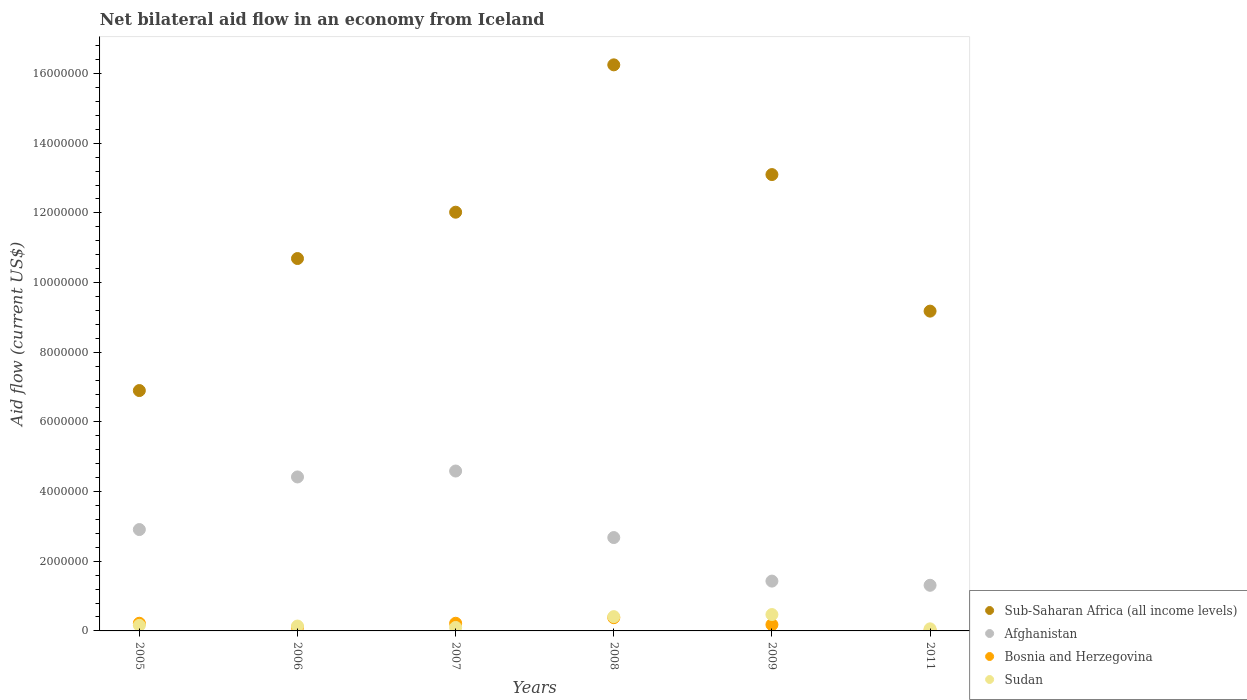How many different coloured dotlines are there?
Make the answer very short. 4. What is the net bilateral aid flow in Afghanistan in 2007?
Offer a terse response. 4.59e+06. Across all years, what is the maximum net bilateral aid flow in Bosnia and Herzegovina?
Your response must be concise. 3.80e+05. Across all years, what is the minimum net bilateral aid flow in Afghanistan?
Keep it short and to the point. 1.31e+06. In which year was the net bilateral aid flow in Bosnia and Herzegovina maximum?
Your response must be concise. 2008. In which year was the net bilateral aid flow in Sudan minimum?
Provide a succinct answer. 2011. What is the total net bilateral aid flow in Sub-Saharan Africa (all income levels) in the graph?
Provide a short and direct response. 6.81e+07. What is the difference between the net bilateral aid flow in Bosnia and Herzegovina in 2005 and that in 2006?
Your response must be concise. 1.20e+05. What is the difference between the net bilateral aid flow in Sub-Saharan Africa (all income levels) in 2005 and the net bilateral aid flow in Afghanistan in 2008?
Offer a terse response. 4.22e+06. What is the average net bilateral aid flow in Afghanistan per year?
Your answer should be compact. 2.89e+06. In the year 2011, what is the difference between the net bilateral aid flow in Bosnia and Herzegovina and net bilateral aid flow in Sub-Saharan Africa (all income levels)?
Ensure brevity in your answer.  -9.16e+06. Is the net bilateral aid flow in Sudan in 2005 less than that in 2011?
Your response must be concise. No. Is the difference between the net bilateral aid flow in Bosnia and Herzegovina in 2009 and 2011 greater than the difference between the net bilateral aid flow in Sub-Saharan Africa (all income levels) in 2009 and 2011?
Provide a short and direct response. No. What is the difference between the highest and the second highest net bilateral aid flow in Sub-Saharan Africa (all income levels)?
Give a very brief answer. 3.15e+06. What is the difference between the highest and the lowest net bilateral aid flow in Afghanistan?
Keep it short and to the point. 3.28e+06. In how many years, is the net bilateral aid flow in Bosnia and Herzegovina greater than the average net bilateral aid flow in Bosnia and Herzegovina taken over all years?
Your answer should be compact. 3. Is the sum of the net bilateral aid flow in Afghanistan in 2005 and 2007 greater than the maximum net bilateral aid flow in Bosnia and Herzegovina across all years?
Your answer should be compact. Yes. Is it the case that in every year, the sum of the net bilateral aid flow in Afghanistan and net bilateral aid flow in Bosnia and Herzegovina  is greater than the sum of net bilateral aid flow in Sub-Saharan Africa (all income levels) and net bilateral aid flow in Sudan?
Give a very brief answer. No. Does the net bilateral aid flow in Bosnia and Herzegovina monotonically increase over the years?
Keep it short and to the point. No. Is the net bilateral aid flow in Bosnia and Herzegovina strictly greater than the net bilateral aid flow in Sudan over the years?
Ensure brevity in your answer.  No. How many dotlines are there?
Provide a short and direct response. 4. How many years are there in the graph?
Your response must be concise. 6. Are the values on the major ticks of Y-axis written in scientific E-notation?
Give a very brief answer. No. How many legend labels are there?
Provide a short and direct response. 4. How are the legend labels stacked?
Provide a short and direct response. Vertical. What is the title of the graph?
Offer a very short reply. Net bilateral aid flow in an economy from Iceland. Does "Zimbabwe" appear as one of the legend labels in the graph?
Make the answer very short. No. What is the label or title of the X-axis?
Keep it short and to the point. Years. What is the Aid flow (current US$) of Sub-Saharan Africa (all income levels) in 2005?
Offer a terse response. 6.90e+06. What is the Aid flow (current US$) of Afghanistan in 2005?
Ensure brevity in your answer.  2.91e+06. What is the Aid flow (current US$) of Bosnia and Herzegovina in 2005?
Ensure brevity in your answer.  2.20e+05. What is the Aid flow (current US$) of Sub-Saharan Africa (all income levels) in 2006?
Your answer should be compact. 1.07e+07. What is the Aid flow (current US$) in Afghanistan in 2006?
Provide a succinct answer. 4.42e+06. What is the Aid flow (current US$) in Sudan in 2006?
Keep it short and to the point. 1.40e+05. What is the Aid flow (current US$) in Sub-Saharan Africa (all income levels) in 2007?
Provide a succinct answer. 1.20e+07. What is the Aid flow (current US$) in Afghanistan in 2007?
Give a very brief answer. 4.59e+06. What is the Aid flow (current US$) in Sudan in 2007?
Ensure brevity in your answer.  1.00e+05. What is the Aid flow (current US$) in Sub-Saharan Africa (all income levels) in 2008?
Provide a short and direct response. 1.62e+07. What is the Aid flow (current US$) of Afghanistan in 2008?
Ensure brevity in your answer.  2.68e+06. What is the Aid flow (current US$) of Sudan in 2008?
Provide a succinct answer. 4.10e+05. What is the Aid flow (current US$) in Sub-Saharan Africa (all income levels) in 2009?
Offer a terse response. 1.31e+07. What is the Aid flow (current US$) in Afghanistan in 2009?
Your answer should be compact. 1.43e+06. What is the Aid flow (current US$) of Bosnia and Herzegovina in 2009?
Offer a terse response. 1.80e+05. What is the Aid flow (current US$) in Sudan in 2009?
Offer a terse response. 4.70e+05. What is the Aid flow (current US$) in Sub-Saharan Africa (all income levels) in 2011?
Your response must be concise. 9.18e+06. What is the Aid flow (current US$) of Afghanistan in 2011?
Offer a very short reply. 1.31e+06. What is the Aid flow (current US$) in Bosnia and Herzegovina in 2011?
Offer a very short reply. 2.00e+04. Across all years, what is the maximum Aid flow (current US$) of Sub-Saharan Africa (all income levels)?
Your response must be concise. 1.62e+07. Across all years, what is the maximum Aid flow (current US$) of Afghanistan?
Offer a terse response. 4.59e+06. Across all years, what is the minimum Aid flow (current US$) in Sub-Saharan Africa (all income levels)?
Make the answer very short. 6.90e+06. Across all years, what is the minimum Aid flow (current US$) in Afghanistan?
Make the answer very short. 1.31e+06. Across all years, what is the minimum Aid flow (current US$) in Bosnia and Herzegovina?
Give a very brief answer. 2.00e+04. What is the total Aid flow (current US$) of Sub-Saharan Africa (all income levels) in the graph?
Your response must be concise. 6.81e+07. What is the total Aid flow (current US$) of Afghanistan in the graph?
Your answer should be very brief. 1.73e+07. What is the total Aid flow (current US$) in Bosnia and Herzegovina in the graph?
Your answer should be very brief. 1.12e+06. What is the total Aid flow (current US$) in Sudan in the graph?
Offer a terse response. 1.34e+06. What is the difference between the Aid flow (current US$) of Sub-Saharan Africa (all income levels) in 2005 and that in 2006?
Your answer should be compact. -3.79e+06. What is the difference between the Aid flow (current US$) of Afghanistan in 2005 and that in 2006?
Offer a terse response. -1.51e+06. What is the difference between the Aid flow (current US$) of Sub-Saharan Africa (all income levels) in 2005 and that in 2007?
Keep it short and to the point. -5.12e+06. What is the difference between the Aid flow (current US$) in Afghanistan in 2005 and that in 2007?
Ensure brevity in your answer.  -1.68e+06. What is the difference between the Aid flow (current US$) of Bosnia and Herzegovina in 2005 and that in 2007?
Offer a very short reply. 0. What is the difference between the Aid flow (current US$) in Sub-Saharan Africa (all income levels) in 2005 and that in 2008?
Your answer should be compact. -9.35e+06. What is the difference between the Aid flow (current US$) of Bosnia and Herzegovina in 2005 and that in 2008?
Your response must be concise. -1.60e+05. What is the difference between the Aid flow (current US$) of Sub-Saharan Africa (all income levels) in 2005 and that in 2009?
Your answer should be compact. -6.20e+06. What is the difference between the Aid flow (current US$) of Afghanistan in 2005 and that in 2009?
Ensure brevity in your answer.  1.48e+06. What is the difference between the Aid flow (current US$) of Bosnia and Herzegovina in 2005 and that in 2009?
Ensure brevity in your answer.  4.00e+04. What is the difference between the Aid flow (current US$) in Sudan in 2005 and that in 2009?
Make the answer very short. -3.10e+05. What is the difference between the Aid flow (current US$) in Sub-Saharan Africa (all income levels) in 2005 and that in 2011?
Give a very brief answer. -2.28e+06. What is the difference between the Aid flow (current US$) of Afghanistan in 2005 and that in 2011?
Provide a succinct answer. 1.60e+06. What is the difference between the Aid flow (current US$) of Bosnia and Herzegovina in 2005 and that in 2011?
Give a very brief answer. 2.00e+05. What is the difference between the Aid flow (current US$) of Sudan in 2005 and that in 2011?
Offer a very short reply. 1.00e+05. What is the difference between the Aid flow (current US$) in Sub-Saharan Africa (all income levels) in 2006 and that in 2007?
Your response must be concise. -1.33e+06. What is the difference between the Aid flow (current US$) of Afghanistan in 2006 and that in 2007?
Your answer should be compact. -1.70e+05. What is the difference between the Aid flow (current US$) of Sudan in 2006 and that in 2007?
Keep it short and to the point. 4.00e+04. What is the difference between the Aid flow (current US$) in Sub-Saharan Africa (all income levels) in 2006 and that in 2008?
Give a very brief answer. -5.56e+06. What is the difference between the Aid flow (current US$) of Afghanistan in 2006 and that in 2008?
Give a very brief answer. 1.74e+06. What is the difference between the Aid flow (current US$) of Bosnia and Herzegovina in 2006 and that in 2008?
Offer a terse response. -2.80e+05. What is the difference between the Aid flow (current US$) in Sudan in 2006 and that in 2008?
Ensure brevity in your answer.  -2.70e+05. What is the difference between the Aid flow (current US$) of Sub-Saharan Africa (all income levels) in 2006 and that in 2009?
Keep it short and to the point. -2.41e+06. What is the difference between the Aid flow (current US$) in Afghanistan in 2006 and that in 2009?
Ensure brevity in your answer.  2.99e+06. What is the difference between the Aid flow (current US$) of Sudan in 2006 and that in 2009?
Your answer should be compact. -3.30e+05. What is the difference between the Aid flow (current US$) of Sub-Saharan Africa (all income levels) in 2006 and that in 2011?
Offer a terse response. 1.51e+06. What is the difference between the Aid flow (current US$) of Afghanistan in 2006 and that in 2011?
Keep it short and to the point. 3.11e+06. What is the difference between the Aid flow (current US$) of Sub-Saharan Africa (all income levels) in 2007 and that in 2008?
Ensure brevity in your answer.  -4.23e+06. What is the difference between the Aid flow (current US$) of Afghanistan in 2007 and that in 2008?
Your response must be concise. 1.91e+06. What is the difference between the Aid flow (current US$) in Sudan in 2007 and that in 2008?
Ensure brevity in your answer.  -3.10e+05. What is the difference between the Aid flow (current US$) of Sub-Saharan Africa (all income levels) in 2007 and that in 2009?
Your answer should be compact. -1.08e+06. What is the difference between the Aid flow (current US$) of Afghanistan in 2007 and that in 2009?
Offer a very short reply. 3.16e+06. What is the difference between the Aid flow (current US$) in Bosnia and Herzegovina in 2007 and that in 2009?
Offer a terse response. 4.00e+04. What is the difference between the Aid flow (current US$) of Sudan in 2007 and that in 2009?
Make the answer very short. -3.70e+05. What is the difference between the Aid flow (current US$) of Sub-Saharan Africa (all income levels) in 2007 and that in 2011?
Your response must be concise. 2.84e+06. What is the difference between the Aid flow (current US$) of Afghanistan in 2007 and that in 2011?
Your answer should be compact. 3.28e+06. What is the difference between the Aid flow (current US$) in Bosnia and Herzegovina in 2007 and that in 2011?
Offer a very short reply. 2.00e+05. What is the difference between the Aid flow (current US$) in Sudan in 2007 and that in 2011?
Provide a succinct answer. 4.00e+04. What is the difference between the Aid flow (current US$) in Sub-Saharan Africa (all income levels) in 2008 and that in 2009?
Your answer should be compact. 3.15e+06. What is the difference between the Aid flow (current US$) in Afghanistan in 2008 and that in 2009?
Your response must be concise. 1.25e+06. What is the difference between the Aid flow (current US$) in Bosnia and Herzegovina in 2008 and that in 2009?
Your answer should be very brief. 2.00e+05. What is the difference between the Aid flow (current US$) in Sudan in 2008 and that in 2009?
Give a very brief answer. -6.00e+04. What is the difference between the Aid flow (current US$) in Sub-Saharan Africa (all income levels) in 2008 and that in 2011?
Keep it short and to the point. 7.07e+06. What is the difference between the Aid flow (current US$) of Afghanistan in 2008 and that in 2011?
Ensure brevity in your answer.  1.37e+06. What is the difference between the Aid flow (current US$) in Bosnia and Herzegovina in 2008 and that in 2011?
Provide a short and direct response. 3.60e+05. What is the difference between the Aid flow (current US$) of Sub-Saharan Africa (all income levels) in 2009 and that in 2011?
Offer a terse response. 3.92e+06. What is the difference between the Aid flow (current US$) of Afghanistan in 2009 and that in 2011?
Your response must be concise. 1.20e+05. What is the difference between the Aid flow (current US$) in Bosnia and Herzegovina in 2009 and that in 2011?
Make the answer very short. 1.60e+05. What is the difference between the Aid flow (current US$) in Sudan in 2009 and that in 2011?
Provide a short and direct response. 4.10e+05. What is the difference between the Aid flow (current US$) in Sub-Saharan Africa (all income levels) in 2005 and the Aid flow (current US$) in Afghanistan in 2006?
Keep it short and to the point. 2.48e+06. What is the difference between the Aid flow (current US$) of Sub-Saharan Africa (all income levels) in 2005 and the Aid flow (current US$) of Bosnia and Herzegovina in 2006?
Offer a very short reply. 6.80e+06. What is the difference between the Aid flow (current US$) of Sub-Saharan Africa (all income levels) in 2005 and the Aid flow (current US$) of Sudan in 2006?
Keep it short and to the point. 6.76e+06. What is the difference between the Aid flow (current US$) in Afghanistan in 2005 and the Aid flow (current US$) in Bosnia and Herzegovina in 2006?
Your response must be concise. 2.81e+06. What is the difference between the Aid flow (current US$) in Afghanistan in 2005 and the Aid flow (current US$) in Sudan in 2006?
Offer a terse response. 2.77e+06. What is the difference between the Aid flow (current US$) of Bosnia and Herzegovina in 2005 and the Aid flow (current US$) of Sudan in 2006?
Ensure brevity in your answer.  8.00e+04. What is the difference between the Aid flow (current US$) of Sub-Saharan Africa (all income levels) in 2005 and the Aid flow (current US$) of Afghanistan in 2007?
Provide a succinct answer. 2.31e+06. What is the difference between the Aid flow (current US$) of Sub-Saharan Africa (all income levels) in 2005 and the Aid flow (current US$) of Bosnia and Herzegovina in 2007?
Offer a terse response. 6.68e+06. What is the difference between the Aid flow (current US$) of Sub-Saharan Africa (all income levels) in 2005 and the Aid flow (current US$) of Sudan in 2007?
Provide a short and direct response. 6.80e+06. What is the difference between the Aid flow (current US$) of Afghanistan in 2005 and the Aid flow (current US$) of Bosnia and Herzegovina in 2007?
Ensure brevity in your answer.  2.69e+06. What is the difference between the Aid flow (current US$) of Afghanistan in 2005 and the Aid flow (current US$) of Sudan in 2007?
Keep it short and to the point. 2.81e+06. What is the difference between the Aid flow (current US$) of Sub-Saharan Africa (all income levels) in 2005 and the Aid flow (current US$) of Afghanistan in 2008?
Make the answer very short. 4.22e+06. What is the difference between the Aid flow (current US$) of Sub-Saharan Africa (all income levels) in 2005 and the Aid flow (current US$) of Bosnia and Herzegovina in 2008?
Ensure brevity in your answer.  6.52e+06. What is the difference between the Aid flow (current US$) of Sub-Saharan Africa (all income levels) in 2005 and the Aid flow (current US$) of Sudan in 2008?
Offer a terse response. 6.49e+06. What is the difference between the Aid flow (current US$) in Afghanistan in 2005 and the Aid flow (current US$) in Bosnia and Herzegovina in 2008?
Provide a short and direct response. 2.53e+06. What is the difference between the Aid flow (current US$) in Afghanistan in 2005 and the Aid flow (current US$) in Sudan in 2008?
Your response must be concise. 2.50e+06. What is the difference between the Aid flow (current US$) of Bosnia and Herzegovina in 2005 and the Aid flow (current US$) of Sudan in 2008?
Offer a terse response. -1.90e+05. What is the difference between the Aid flow (current US$) in Sub-Saharan Africa (all income levels) in 2005 and the Aid flow (current US$) in Afghanistan in 2009?
Provide a succinct answer. 5.47e+06. What is the difference between the Aid flow (current US$) in Sub-Saharan Africa (all income levels) in 2005 and the Aid flow (current US$) in Bosnia and Herzegovina in 2009?
Provide a short and direct response. 6.72e+06. What is the difference between the Aid flow (current US$) in Sub-Saharan Africa (all income levels) in 2005 and the Aid flow (current US$) in Sudan in 2009?
Provide a short and direct response. 6.43e+06. What is the difference between the Aid flow (current US$) in Afghanistan in 2005 and the Aid flow (current US$) in Bosnia and Herzegovina in 2009?
Ensure brevity in your answer.  2.73e+06. What is the difference between the Aid flow (current US$) in Afghanistan in 2005 and the Aid flow (current US$) in Sudan in 2009?
Make the answer very short. 2.44e+06. What is the difference between the Aid flow (current US$) in Bosnia and Herzegovina in 2005 and the Aid flow (current US$) in Sudan in 2009?
Make the answer very short. -2.50e+05. What is the difference between the Aid flow (current US$) in Sub-Saharan Africa (all income levels) in 2005 and the Aid flow (current US$) in Afghanistan in 2011?
Provide a succinct answer. 5.59e+06. What is the difference between the Aid flow (current US$) of Sub-Saharan Africa (all income levels) in 2005 and the Aid flow (current US$) of Bosnia and Herzegovina in 2011?
Your answer should be very brief. 6.88e+06. What is the difference between the Aid flow (current US$) in Sub-Saharan Africa (all income levels) in 2005 and the Aid flow (current US$) in Sudan in 2011?
Your answer should be very brief. 6.84e+06. What is the difference between the Aid flow (current US$) in Afghanistan in 2005 and the Aid flow (current US$) in Bosnia and Herzegovina in 2011?
Provide a short and direct response. 2.89e+06. What is the difference between the Aid flow (current US$) of Afghanistan in 2005 and the Aid flow (current US$) of Sudan in 2011?
Your response must be concise. 2.85e+06. What is the difference between the Aid flow (current US$) in Bosnia and Herzegovina in 2005 and the Aid flow (current US$) in Sudan in 2011?
Offer a very short reply. 1.60e+05. What is the difference between the Aid flow (current US$) in Sub-Saharan Africa (all income levels) in 2006 and the Aid flow (current US$) in Afghanistan in 2007?
Make the answer very short. 6.10e+06. What is the difference between the Aid flow (current US$) in Sub-Saharan Africa (all income levels) in 2006 and the Aid flow (current US$) in Bosnia and Herzegovina in 2007?
Your response must be concise. 1.05e+07. What is the difference between the Aid flow (current US$) in Sub-Saharan Africa (all income levels) in 2006 and the Aid flow (current US$) in Sudan in 2007?
Give a very brief answer. 1.06e+07. What is the difference between the Aid flow (current US$) of Afghanistan in 2006 and the Aid flow (current US$) of Bosnia and Herzegovina in 2007?
Your answer should be very brief. 4.20e+06. What is the difference between the Aid flow (current US$) of Afghanistan in 2006 and the Aid flow (current US$) of Sudan in 2007?
Your response must be concise. 4.32e+06. What is the difference between the Aid flow (current US$) of Bosnia and Herzegovina in 2006 and the Aid flow (current US$) of Sudan in 2007?
Your response must be concise. 0. What is the difference between the Aid flow (current US$) in Sub-Saharan Africa (all income levels) in 2006 and the Aid flow (current US$) in Afghanistan in 2008?
Give a very brief answer. 8.01e+06. What is the difference between the Aid flow (current US$) in Sub-Saharan Africa (all income levels) in 2006 and the Aid flow (current US$) in Bosnia and Herzegovina in 2008?
Make the answer very short. 1.03e+07. What is the difference between the Aid flow (current US$) in Sub-Saharan Africa (all income levels) in 2006 and the Aid flow (current US$) in Sudan in 2008?
Provide a short and direct response. 1.03e+07. What is the difference between the Aid flow (current US$) in Afghanistan in 2006 and the Aid flow (current US$) in Bosnia and Herzegovina in 2008?
Make the answer very short. 4.04e+06. What is the difference between the Aid flow (current US$) of Afghanistan in 2006 and the Aid flow (current US$) of Sudan in 2008?
Make the answer very short. 4.01e+06. What is the difference between the Aid flow (current US$) in Bosnia and Herzegovina in 2006 and the Aid flow (current US$) in Sudan in 2008?
Provide a short and direct response. -3.10e+05. What is the difference between the Aid flow (current US$) of Sub-Saharan Africa (all income levels) in 2006 and the Aid flow (current US$) of Afghanistan in 2009?
Provide a short and direct response. 9.26e+06. What is the difference between the Aid flow (current US$) in Sub-Saharan Africa (all income levels) in 2006 and the Aid flow (current US$) in Bosnia and Herzegovina in 2009?
Offer a very short reply. 1.05e+07. What is the difference between the Aid flow (current US$) in Sub-Saharan Africa (all income levels) in 2006 and the Aid flow (current US$) in Sudan in 2009?
Make the answer very short. 1.02e+07. What is the difference between the Aid flow (current US$) of Afghanistan in 2006 and the Aid flow (current US$) of Bosnia and Herzegovina in 2009?
Provide a succinct answer. 4.24e+06. What is the difference between the Aid flow (current US$) of Afghanistan in 2006 and the Aid flow (current US$) of Sudan in 2009?
Offer a terse response. 3.95e+06. What is the difference between the Aid flow (current US$) of Bosnia and Herzegovina in 2006 and the Aid flow (current US$) of Sudan in 2009?
Your answer should be compact. -3.70e+05. What is the difference between the Aid flow (current US$) of Sub-Saharan Africa (all income levels) in 2006 and the Aid flow (current US$) of Afghanistan in 2011?
Your answer should be very brief. 9.38e+06. What is the difference between the Aid flow (current US$) of Sub-Saharan Africa (all income levels) in 2006 and the Aid flow (current US$) of Bosnia and Herzegovina in 2011?
Provide a succinct answer. 1.07e+07. What is the difference between the Aid flow (current US$) in Sub-Saharan Africa (all income levels) in 2006 and the Aid flow (current US$) in Sudan in 2011?
Provide a short and direct response. 1.06e+07. What is the difference between the Aid flow (current US$) in Afghanistan in 2006 and the Aid flow (current US$) in Bosnia and Herzegovina in 2011?
Your response must be concise. 4.40e+06. What is the difference between the Aid flow (current US$) of Afghanistan in 2006 and the Aid flow (current US$) of Sudan in 2011?
Provide a short and direct response. 4.36e+06. What is the difference between the Aid flow (current US$) of Sub-Saharan Africa (all income levels) in 2007 and the Aid flow (current US$) of Afghanistan in 2008?
Give a very brief answer. 9.34e+06. What is the difference between the Aid flow (current US$) in Sub-Saharan Africa (all income levels) in 2007 and the Aid flow (current US$) in Bosnia and Herzegovina in 2008?
Offer a terse response. 1.16e+07. What is the difference between the Aid flow (current US$) of Sub-Saharan Africa (all income levels) in 2007 and the Aid flow (current US$) of Sudan in 2008?
Keep it short and to the point. 1.16e+07. What is the difference between the Aid flow (current US$) of Afghanistan in 2007 and the Aid flow (current US$) of Bosnia and Herzegovina in 2008?
Offer a terse response. 4.21e+06. What is the difference between the Aid flow (current US$) in Afghanistan in 2007 and the Aid flow (current US$) in Sudan in 2008?
Give a very brief answer. 4.18e+06. What is the difference between the Aid flow (current US$) in Sub-Saharan Africa (all income levels) in 2007 and the Aid flow (current US$) in Afghanistan in 2009?
Ensure brevity in your answer.  1.06e+07. What is the difference between the Aid flow (current US$) of Sub-Saharan Africa (all income levels) in 2007 and the Aid flow (current US$) of Bosnia and Herzegovina in 2009?
Keep it short and to the point. 1.18e+07. What is the difference between the Aid flow (current US$) of Sub-Saharan Africa (all income levels) in 2007 and the Aid flow (current US$) of Sudan in 2009?
Offer a terse response. 1.16e+07. What is the difference between the Aid flow (current US$) in Afghanistan in 2007 and the Aid flow (current US$) in Bosnia and Herzegovina in 2009?
Provide a succinct answer. 4.41e+06. What is the difference between the Aid flow (current US$) of Afghanistan in 2007 and the Aid flow (current US$) of Sudan in 2009?
Offer a terse response. 4.12e+06. What is the difference between the Aid flow (current US$) in Sub-Saharan Africa (all income levels) in 2007 and the Aid flow (current US$) in Afghanistan in 2011?
Keep it short and to the point. 1.07e+07. What is the difference between the Aid flow (current US$) of Sub-Saharan Africa (all income levels) in 2007 and the Aid flow (current US$) of Sudan in 2011?
Offer a terse response. 1.20e+07. What is the difference between the Aid flow (current US$) of Afghanistan in 2007 and the Aid flow (current US$) of Bosnia and Herzegovina in 2011?
Provide a succinct answer. 4.57e+06. What is the difference between the Aid flow (current US$) of Afghanistan in 2007 and the Aid flow (current US$) of Sudan in 2011?
Your answer should be very brief. 4.53e+06. What is the difference between the Aid flow (current US$) of Bosnia and Herzegovina in 2007 and the Aid flow (current US$) of Sudan in 2011?
Give a very brief answer. 1.60e+05. What is the difference between the Aid flow (current US$) of Sub-Saharan Africa (all income levels) in 2008 and the Aid flow (current US$) of Afghanistan in 2009?
Offer a terse response. 1.48e+07. What is the difference between the Aid flow (current US$) of Sub-Saharan Africa (all income levels) in 2008 and the Aid flow (current US$) of Bosnia and Herzegovina in 2009?
Ensure brevity in your answer.  1.61e+07. What is the difference between the Aid flow (current US$) of Sub-Saharan Africa (all income levels) in 2008 and the Aid flow (current US$) of Sudan in 2009?
Offer a terse response. 1.58e+07. What is the difference between the Aid flow (current US$) of Afghanistan in 2008 and the Aid flow (current US$) of Bosnia and Herzegovina in 2009?
Keep it short and to the point. 2.50e+06. What is the difference between the Aid flow (current US$) of Afghanistan in 2008 and the Aid flow (current US$) of Sudan in 2009?
Provide a short and direct response. 2.21e+06. What is the difference between the Aid flow (current US$) of Bosnia and Herzegovina in 2008 and the Aid flow (current US$) of Sudan in 2009?
Provide a succinct answer. -9.00e+04. What is the difference between the Aid flow (current US$) in Sub-Saharan Africa (all income levels) in 2008 and the Aid flow (current US$) in Afghanistan in 2011?
Your response must be concise. 1.49e+07. What is the difference between the Aid flow (current US$) of Sub-Saharan Africa (all income levels) in 2008 and the Aid flow (current US$) of Bosnia and Herzegovina in 2011?
Your response must be concise. 1.62e+07. What is the difference between the Aid flow (current US$) in Sub-Saharan Africa (all income levels) in 2008 and the Aid flow (current US$) in Sudan in 2011?
Keep it short and to the point. 1.62e+07. What is the difference between the Aid flow (current US$) of Afghanistan in 2008 and the Aid flow (current US$) of Bosnia and Herzegovina in 2011?
Ensure brevity in your answer.  2.66e+06. What is the difference between the Aid flow (current US$) in Afghanistan in 2008 and the Aid flow (current US$) in Sudan in 2011?
Provide a short and direct response. 2.62e+06. What is the difference between the Aid flow (current US$) in Bosnia and Herzegovina in 2008 and the Aid flow (current US$) in Sudan in 2011?
Offer a terse response. 3.20e+05. What is the difference between the Aid flow (current US$) of Sub-Saharan Africa (all income levels) in 2009 and the Aid flow (current US$) of Afghanistan in 2011?
Offer a very short reply. 1.18e+07. What is the difference between the Aid flow (current US$) in Sub-Saharan Africa (all income levels) in 2009 and the Aid flow (current US$) in Bosnia and Herzegovina in 2011?
Offer a very short reply. 1.31e+07. What is the difference between the Aid flow (current US$) of Sub-Saharan Africa (all income levels) in 2009 and the Aid flow (current US$) of Sudan in 2011?
Keep it short and to the point. 1.30e+07. What is the difference between the Aid flow (current US$) in Afghanistan in 2009 and the Aid flow (current US$) in Bosnia and Herzegovina in 2011?
Provide a succinct answer. 1.41e+06. What is the difference between the Aid flow (current US$) in Afghanistan in 2009 and the Aid flow (current US$) in Sudan in 2011?
Offer a very short reply. 1.37e+06. What is the average Aid flow (current US$) of Sub-Saharan Africa (all income levels) per year?
Your answer should be compact. 1.14e+07. What is the average Aid flow (current US$) in Afghanistan per year?
Offer a terse response. 2.89e+06. What is the average Aid flow (current US$) of Bosnia and Herzegovina per year?
Your answer should be compact. 1.87e+05. What is the average Aid flow (current US$) of Sudan per year?
Your answer should be very brief. 2.23e+05. In the year 2005, what is the difference between the Aid flow (current US$) of Sub-Saharan Africa (all income levels) and Aid flow (current US$) of Afghanistan?
Offer a very short reply. 3.99e+06. In the year 2005, what is the difference between the Aid flow (current US$) in Sub-Saharan Africa (all income levels) and Aid flow (current US$) in Bosnia and Herzegovina?
Ensure brevity in your answer.  6.68e+06. In the year 2005, what is the difference between the Aid flow (current US$) in Sub-Saharan Africa (all income levels) and Aid flow (current US$) in Sudan?
Your response must be concise. 6.74e+06. In the year 2005, what is the difference between the Aid flow (current US$) of Afghanistan and Aid flow (current US$) of Bosnia and Herzegovina?
Your answer should be compact. 2.69e+06. In the year 2005, what is the difference between the Aid flow (current US$) in Afghanistan and Aid flow (current US$) in Sudan?
Give a very brief answer. 2.75e+06. In the year 2006, what is the difference between the Aid flow (current US$) of Sub-Saharan Africa (all income levels) and Aid flow (current US$) of Afghanistan?
Your answer should be very brief. 6.27e+06. In the year 2006, what is the difference between the Aid flow (current US$) of Sub-Saharan Africa (all income levels) and Aid flow (current US$) of Bosnia and Herzegovina?
Provide a short and direct response. 1.06e+07. In the year 2006, what is the difference between the Aid flow (current US$) of Sub-Saharan Africa (all income levels) and Aid flow (current US$) of Sudan?
Offer a terse response. 1.06e+07. In the year 2006, what is the difference between the Aid flow (current US$) in Afghanistan and Aid flow (current US$) in Bosnia and Herzegovina?
Ensure brevity in your answer.  4.32e+06. In the year 2006, what is the difference between the Aid flow (current US$) of Afghanistan and Aid flow (current US$) of Sudan?
Make the answer very short. 4.28e+06. In the year 2006, what is the difference between the Aid flow (current US$) of Bosnia and Herzegovina and Aid flow (current US$) of Sudan?
Keep it short and to the point. -4.00e+04. In the year 2007, what is the difference between the Aid flow (current US$) of Sub-Saharan Africa (all income levels) and Aid flow (current US$) of Afghanistan?
Offer a very short reply. 7.43e+06. In the year 2007, what is the difference between the Aid flow (current US$) of Sub-Saharan Africa (all income levels) and Aid flow (current US$) of Bosnia and Herzegovina?
Your answer should be very brief. 1.18e+07. In the year 2007, what is the difference between the Aid flow (current US$) of Sub-Saharan Africa (all income levels) and Aid flow (current US$) of Sudan?
Make the answer very short. 1.19e+07. In the year 2007, what is the difference between the Aid flow (current US$) in Afghanistan and Aid flow (current US$) in Bosnia and Herzegovina?
Your response must be concise. 4.37e+06. In the year 2007, what is the difference between the Aid flow (current US$) of Afghanistan and Aid flow (current US$) of Sudan?
Your answer should be very brief. 4.49e+06. In the year 2008, what is the difference between the Aid flow (current US$) in Sub-Saharan Africa (all income levels) and Aid flow (current US$) in Afghanistan?
Provide a succinct answer. 1.36e+07. In the year 2008, what is the difference between the Aid flow (current US$) in Sub-Saharan Africa (all income levels) and Aid flow (current US$) in Bosnia and Herzegovina?
Keep it short and to the point. 1.59e+07. In the year 2008, what is the difference between the Aid flow (current US$) of Sub-Saharan Africa (all income levels) and Aid flow (current US$) of Sudan?
Make the answer very short. 1.58e+07. In the year 2008, what is the difference between the Aid flow (current US$) in Afghanistan and Aid flow (current US$) in Bosnia and Herzegovina?
Offer a very short reply. 2.30e+06. In the year 2008, what is the difference between the Aid flow (current US$) of Afghanistan and Aid flow (current US$) of Sudan?
Provide a succinct answer. 2.27e+06. In the year 2009, what is the difference between the Aid flow (current US$) in Sub-Saharan Africa (all income levels) and Aid flow (current US$) in Afghanistan?
Your answer should be very brief. 1.17e+07. In the year 2009, what is the difference between the Aid flow (current US$) in Sub-Saharan Africa (all income levels) and Aid flow (current US$) in Bosnia and Herzegovina?
Offer a very short reply. 1.29e+07. In the year 2009, what is the difference between the Aid flow (current US$) in Sub-Saharan Africa (all income levels) and Aid flow (current US$) in Sudan?
Your answer should be very brief. 1.26e+07. In the year 2009, what is the difference between the Aid flow (current US$) of Afghanistan and Aid flow (current US$) of Bosnia and Herzegovina?
Provide a succinct answer. 1.25e+06. In the year 2009, what is the difference between the Aid flow (current US$) in Afghanistan and Aid flow (current US$) in Sudan?
Your response must be concise. 9.60e+05. In the year 2009, what is the difference between the Aid flow (current US$) in Bosnia and Herzegovina and Aid flow (current US$) in Sudan?
Your answer should be compact. -2.90e+05. In the year 2011, what is the difference between the Aid flow (current US$) of Sub-Saharan Africa (all income levels) and Aid flow (current US$) of Afghanistan?
Offer a very short reply. 7.87e+06. In the year 2011, what is the difference between the Aid flow (current US$) of Sub-Saharan Africa (all income levels) and Aid flow (current US$) of Bosnia and Herzegovina?
Provide a succinct answer. 9.16e+06. In the year 2011, what is the difference between the Aid flow (current US$) of Sub-Saharan Africa (all income levels) and Aid flow (current US$) of Sudan?
Keep it short and to the point. 9.12e+06. In the year 2011, what is the difference between the Aid flow (current US$) in Afghanistan and Aid flow (current US$) in Bosnia and Herzegovina?
Your answer should be compact. 1.29e+06. In the year 2011, what is the difference between the Aid flow (current US$) of Afghanistan and Aid flow (current US$) of Sudan?
Offer a terse response. 1.25e+06. What is the ratio of the Aid flow (current US$) in Sub-Saharan Africa (all income levels) in 2005 to that in 2006?
Your response must be concise. 0.65. What is the ratio of the Aid flow (current US$) in Afghanistan in 2005 to that in 2006?
Ensure brevity in your answer.  0.66. What is the ratio of the Aid flow (current US$) in Sudan in 2005 to that in 2006?
Ensure brevity in your answer.  1.14. What is the ratio of the Aid flow (current US$) in Sub-Saharan Africa (all income levels) in 2005 to that in 2007?
Provide a short and direct response. 0.57. What is the ratio of the Aid flow (current US$) in Afghanistan in 2005 to that in 2007?
Provide a short and direct response. 0.63. What is the ratio of the Aid flow (current US$) of Bosnia and Herzegovina in 2005 to that in 2007?
Provide a succinct answer. 1. What is the ratio of the Aid flow (current US$) in Sub-Saharan Africa (all income levels) in 2005 to that in 2008?
Offer a terse response. 0.42. What is the ratio of the Aid flow (current US$) of Afghanistan in 2005 to that in 2008?
Give a very brief answer. 1.09. What is the ratio of the Aid flow (current US$) of Bosnia and Herzegovina in 2005 to that in 2008?
Keep it short and to the point. 0.58. What is the ratio of the Aid flow (current US$) in Sudan in 2005 to that in 2008?
Offer a very short reply. 0.39. What is the ratio of the Aid flow (current US$) in Sub-Saharan Africa (all income levels) in 2005 to that in 2009?
Make the answer very short. 0.53. What is the ratio of the Aid flow (current US$) of Afghanistan in 2005 to that in 2009?
Make the answer very short. 2.04. What is the ratio of the Aid flow (current US$) of Bosnia and Herzegovina in 2005 to that in 2009?
Your response must be concise. 1.22. What is the ratio of the Aid flow (current US$) of Sudan in 2005 to that in 2009?
Offer a very short reply. 0.34. What is the ratio of the Aid flow (current US$) in Sub-Saharan Africa (all income levels) in 2005 to that in 2011?
Keep it short and to the point. 0.75. What is the ratio of the Aid flow (current US$) of Afghanistan in 2005 to that in 2011?
Provide a short and direct response. 2.22. What is the ratio of the Aid flow (current US$) in Bosnia and Herzegovina in 2005 to that in 2011?
Make the answer very short. 11. What is the ratio of the Aid flow (current US$) of Sudan in 2005 to that in 2011?
Offer a very short reply. 2.67. What is the ratio of the Aid flow (current US$) of Sub-Saharan Africa (all income levels) in 2006 to that in 2007?
Provide a short and direct response. 0.89. What is the ratio of the Aid flow (current US$) in Afghanistan in 2006 to that in 2007?
Offer a terse response. 0.96. What is the ratio of the Aid flow (current US$) in Bosnia and Herzegovina in 2006 to that in 2007?
Your answer should be very brief. 0.45. What is the ratio of the Aid flow (current US$) of Sudan in 2006 to that in 2007?
Make the answer very short. 1.4. What is the ratio of the Aid flow (current US$) in Sub-Saharan Africa (all income levels) in 2006 to that in 2008?
Your response must be concise. 0.66. What is the ratio of the Aid flow (current US$) of Afghanistan in 2006 to that in 2008?
Ensure brevity in your answer.  1.65. What is the ratio of the Aid flow (current US$) of Bosnia and Herzegovina in 2006 to that in 2008?
Provide a short and direct response. 0.26. What is the ratio of the Aid flow (current US$) in Sudan in 2006 to that in 2008?
Your answer should be very brief. 0.34. What is the ratio of the Aid flow (current US$) of Sub-Saharan Africa (all income levels) in 2006 to that in 2009?
Provide a short and direct response. 0.82. What is the ratio of the Aid flow (current US$) in Afghanistan in 2006 to that in 2009?
Provide a short and direct response. 3.09. What is the ratio of the Aid flow (current US$) in Bosnia and Herzegovina in 2006 to that in 2009?
Your answer should be very brief. 0.56. What is the ratio of the Aid flow (current US$) of Sudan in 2006 to that in 2009?
Ensure brevity in your answer.  0.3. What is the ratio of the Aid flow (current US$) of Sub-Saharan Africa (all income levels) in 2006 to that in 2011?
Give a very brief answer. 1.16. What is the ratio of the Aid flow (current US$) of Afghanistan in 2006 to that in 2011?
Provide a short and direct response. 3.37. What is the ratio of the Aid flow (current US$) of Sudan in 2006 to that in 2011?
Provide a succinct answer. 2.33. What is the ratio of the Aid flow (current US$) in Sub-Saharan Africa (all income levels) in 2007 to that in 2008?
Make the answer very short. 0.74. What is the ratio of the Aid flow (current US$) in Afghanistan in 2007 to that in 2008?
Make the answer very short. 1.71. What is the ratio of the Aid flow (current US$) in Bosnia and Herzegovina in 2007 to that in 2008?
Provide a succinct answer. 0.58. What is the ratio of the Aid flow (current US$) in Sudan in 2007 to that in 2008?
Give a very brief answer. 0.24. What is the ratio of the Aid flow (current US$) of Sub-Saharan Africa (all income levels) in 2007 to that in 2009?
Ensure brevity in your answer.  0.92. What is the ratio of the Aid flow (current US$) of Afghanistan in 2007 to that in 2009?
Make the answer very short. 3.21. What is the ratio of the Aid flow (current US$) of Bosnia and Herzegovina in 2007 to that in 2009?
Provide a succinct answer. 1.22. What is the ratio of the Aid flow (current US$) of Sudan in 2007 to that in 2009?
Ensure brevity in your answer.  0.21. What is the ratio of the Aid flow (current US$) of Sub-Saharan Africa (all income levels) in 2007 to that in 2011?
Your answer should be very brief. 1.31. What is the ratio of the Aid flow (current US$) in Afghanistan in 2007 to that in 2011?
Your response must be concise. 3.5. What is the ratio of the Aid flow (current US$) of Bosnia and Herzegovina in 2007 to that in 2011?
Your answer should be compact. 11. What is the ratio of the Aid flow (current US$) in Sub-Saharan Africa (all income levels) in 2008 to that in 2009?
Your answer should be very brief. 1.24. What is the ratio of the Aid flow (current US$) of Afghanistan in 2008 to that in 2009?
Provide a succinct answer. 1.87. What is the ratio of the Aid flow (current US$) of Bosnia and Herzegovina in 2008 to that in 2009?
Your answer should be very brief. 2.11. What is the ratio of the Aid flow (current US$) in Sudan in 2008 to that in 2009?
Provide a succinct answer. 0.87. What is the ratio of the Aid flow (current US$) of Sub-Saharan Africa (all income levels) in 2008 to that in 2011?
Make the answer very short. 1.77. What is the ratio of the Aid flow (current US$) in Afghanistan in 2008 to that in 2011?
Offer a very short reply. 2.05. What is the ratio of the Aid flow (current US$) in Sudan in 2008 to that in 2011?
Keep it short and to the point. 6.83. What is the ratio of the Aid flow (current US$) in Sub-Saharan Africa (all income levels) in 2009 to that in 2011?
Make the answer very short. 1.43. What is the ratio of the Aid flow (current US$) of Afghanistan in 2009 to that in 2011?
Provide a succinct answer. 1.09. What is the ratio of the Aid flow (current US$) of Bosnia and Herzegovina in 2009 to that in 2011?
Your response must be concise. 9. What is the ratio of the Aid flow (current US$) in Sudan in 2009 to that in 2011?
Provide a short and direct response. 7.83. What is the difference between the highest and the second highest Aid flow (current US$) of Sub-Saharan Africa (all income levels)?
Give a very brief answer. 3.15e+06. What is the difference between the highest and the lowest Aid flow (current US$) of Sub-Saharan Africa (all income levels)?
Provide a short and direct response. 9.35e+06. What is the difference between the highest and the lowest Aid flow (current US$) of Afghanistan?
Your answer should be compact. 3.28e+06. What is the difference between the highest and the lowest Aid flow (current US$) in Sudan?
Make the answer very short. 4.10e+05. 